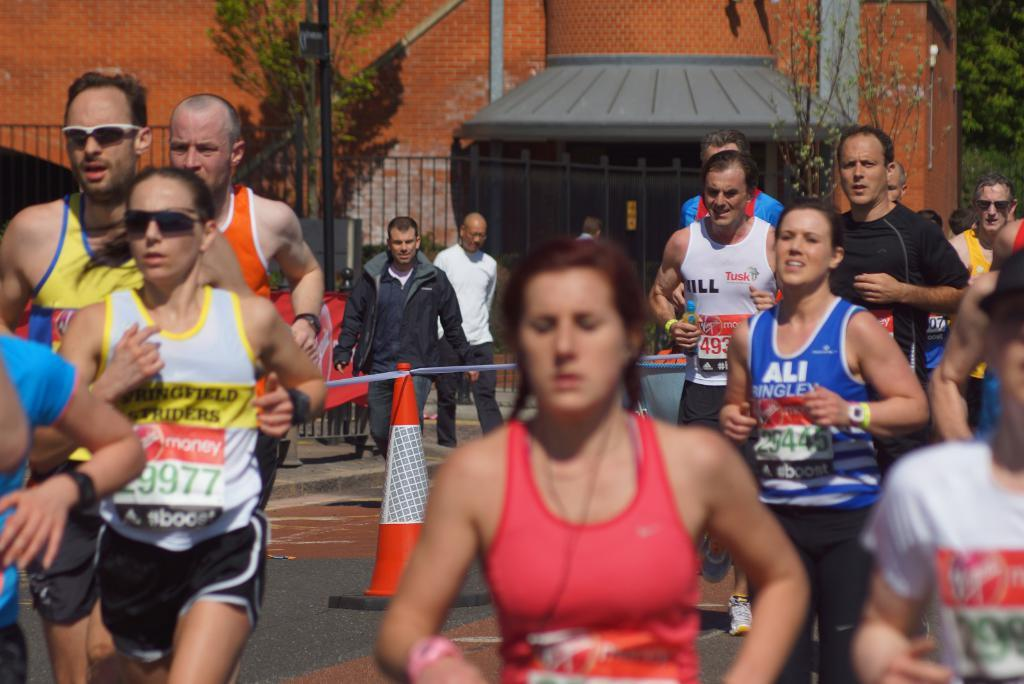Provide a one-sentence caption for the provided image. people in a running race wearing bibs from BOOST. 